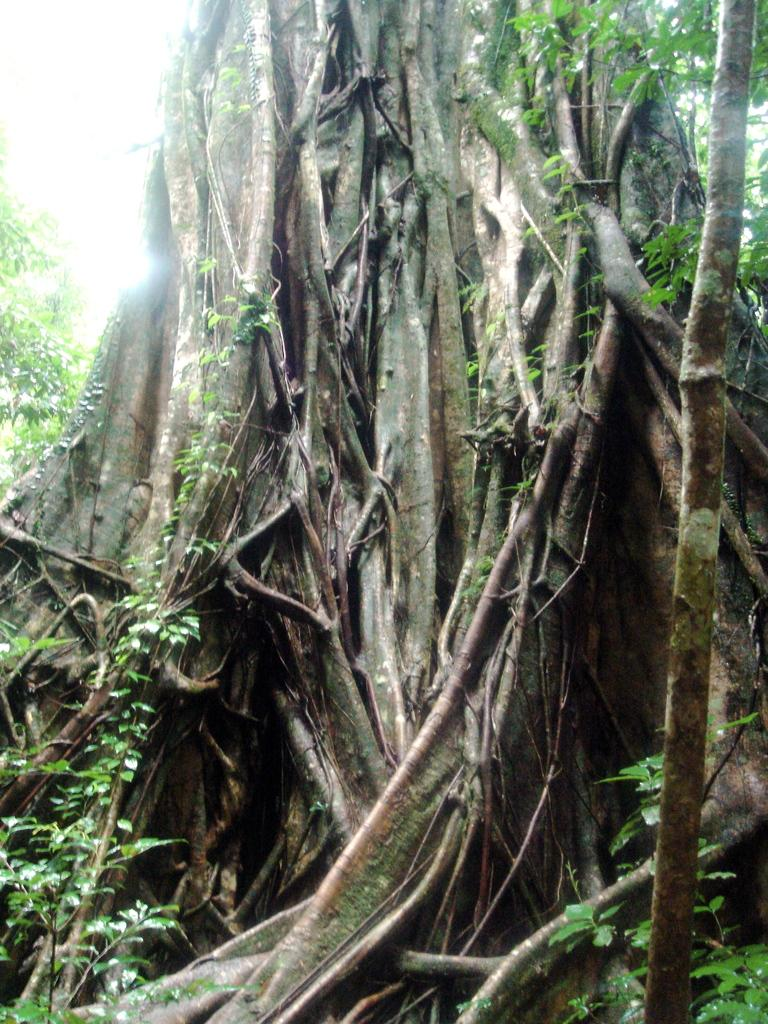What is the most prominent feature in the image? There is a gigantic tree in the image. Can you describe the tree's structure? The tree has many roots and many branches. What type of army is marching through the tree's branches in the image? There is no army or any marching figures present in the image; it only features a gigantic tree with many roots and branches. 